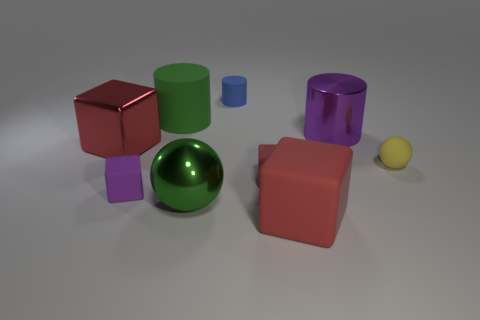Subtract all large matte cubes. How many cubes are left? 3 Subtract all yellow balls. How many red cubes are left? 3 Add 1 purple blocks. How many objects exist? 10 Subtract 3 cylinders. How many cylinders are left? 0 Subtract all purple blocks. How many blocks are left? 3 Subtract 0 gray cylinders. How many objects are left? 9 Subtract all cylinders. How many objects are left? 6 Subtract all gray cylinders. Subtract all brown spheres. How many cylinders are left? 3 Subtract all large metal balls. Subtract all small cylinders. How many objects are left? 7 Add 3 small rubber things. How many small rubber things are left? 7 